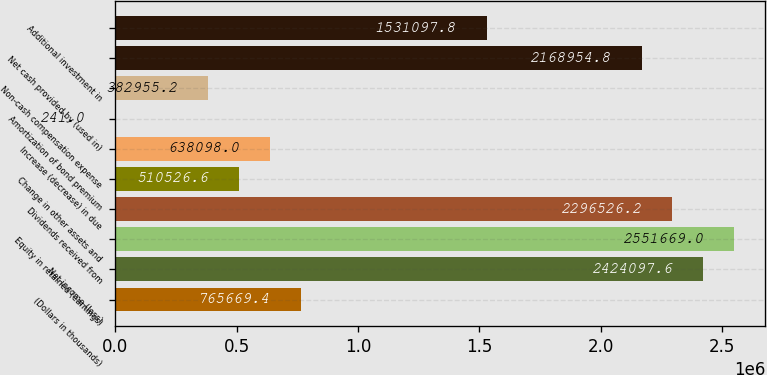Convert chart. <chart><loc_0><loc_0><loc_500><loc_500><bar_chart><fcel>(Dollars in thousands)<fcel>Net income (loss)<fcel>Equity in retained (earnings)<fcel>Dividends received from<fcel>Change in other assets and<fcel>Increase (decrease) in due<fcel>Amortization of bond premium<fcel>Non-cash compensation expense<fcel>Net cash provided by (used in)<fcel>Additional investment in<nl><fcel>765669<fcel>2.4241e+06<fcel>2.55167e+06<fcel>2.29653e+06<fcel>510527<fcel>638098<fcel>241<fcel>382955<fcel>2.16895e+06<fcel>1.5311e+06<nl></chart> 